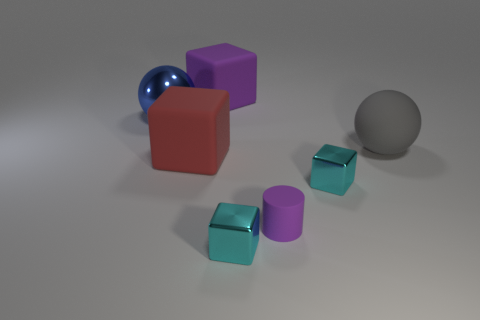Subtract 1 cubes. How many cubes are left? 3 Add 1 cyan metal objects. How many objects exist? 8 Subtract all blocks. How many objects are left? 3 Add 4 big red rubber things. How many big red rubber things are left? 5 Add 1 blue shiny things. How many blue shiny things exist? 2 Subtract 0 green cylinders. How many objects are left? 7 Subtract all matte cylinders. Subtract all big things. How many objects are left? 2 